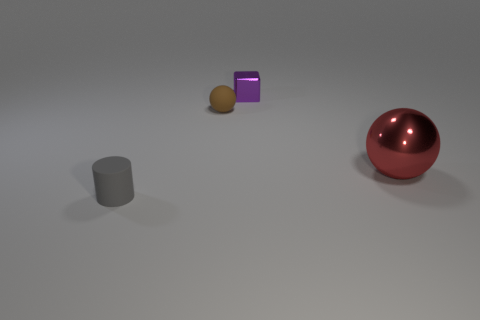What is the shape of the big red metallic thing? The big red metallic object in the image is a perfect sphere with a reflective surface, illustrating the properties of metallic materials such as shine and reflectivity. 